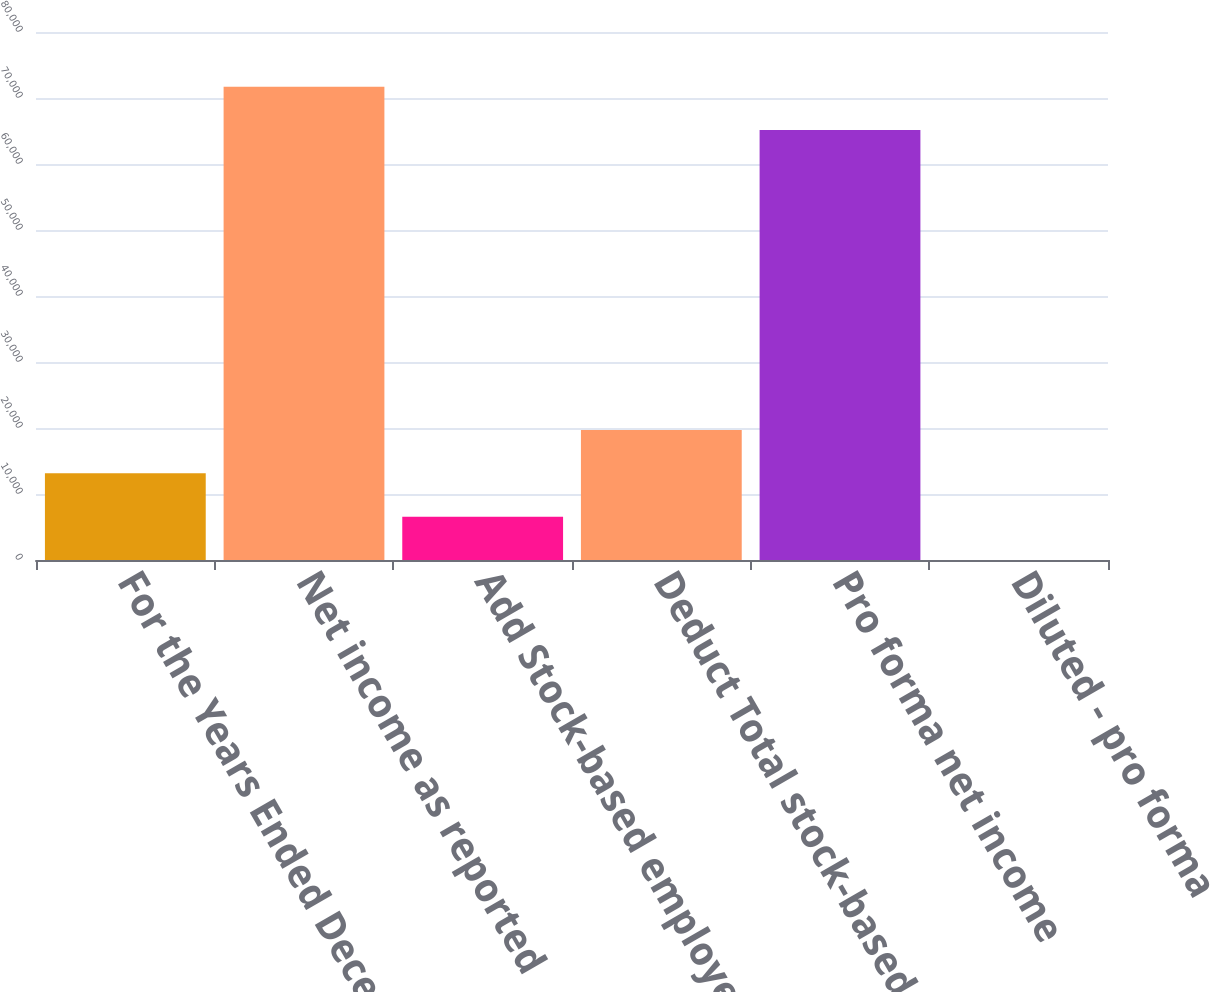Convert chart. <chart><loc_0><loc_0><loc_500><loc_500><bar_chart><fcel>For the Years Ended December<fcel>Net income as reported<fcel>Add Stock-based employee<fcel>Deduct Total stock-based<fcel>Pro forma net income<fcel>Diluted - pro forma<nl><fcel>13142<fcel>71707.5<fcel>6571.44<fcel>19712.5<fcel>65137<fcel>0.93<nl></chart> 